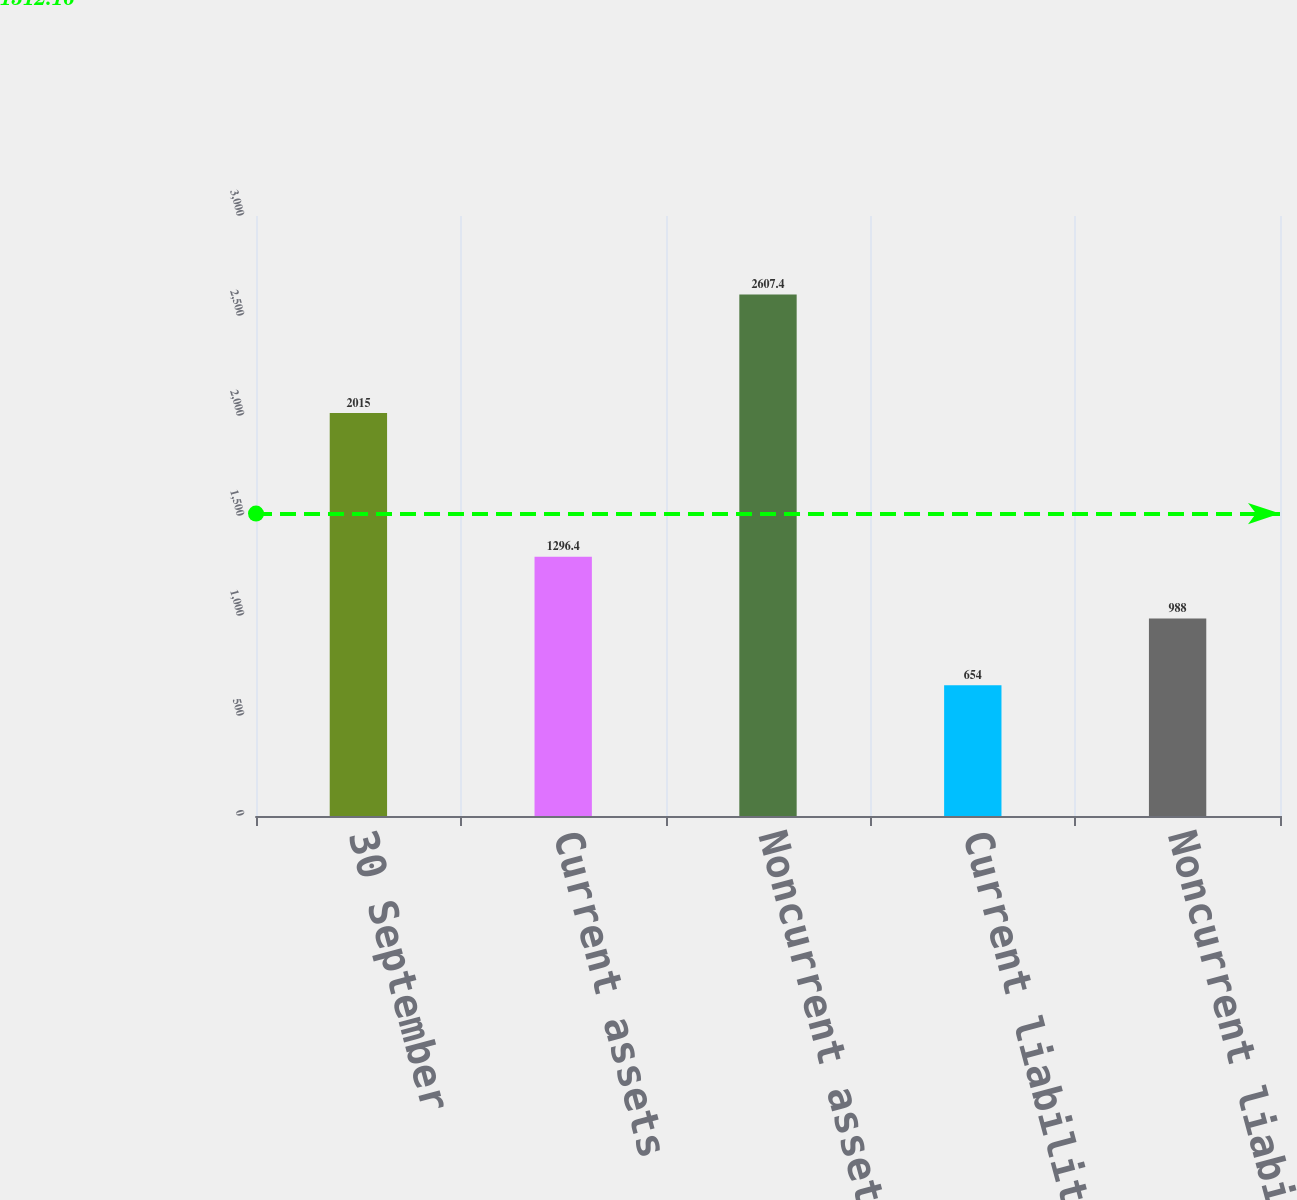<chart> <loc_0><loc_0><loc_500><loc_500><bar_chart><fcel>30 September<fcel>Current assets<fcel>Noncurrent assets<fcel>Current liabilities<fcel>Noncurrent liabilities<nl><fcel>2015<fcel>1296.4<fcel>2607.4<fcel>654<fcel>988<nl></chart> 